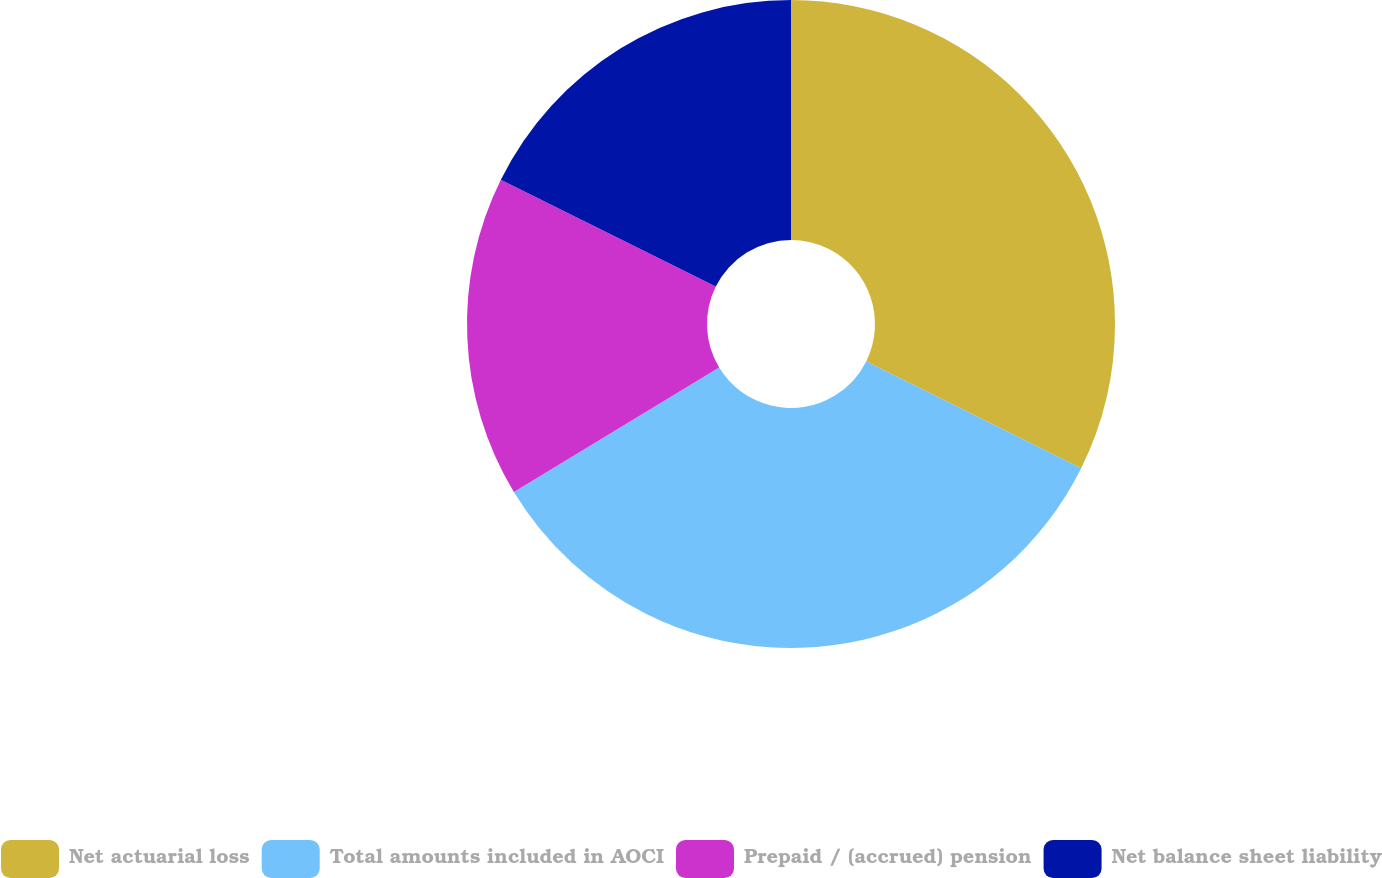Convert chart. <chart><loc_0><loc_0><loc_500><loc_500><pie_chart><fcel>Net actuarial loss<fcel>Total amounts included in AOCI<fcel>Prepaid / (accrued) pension<fcel>Net balance sheet liability<nl><fcel>32.34%<fcel>33.99%<fcel>16.01%<fcel>17.66%<nl></chart> 